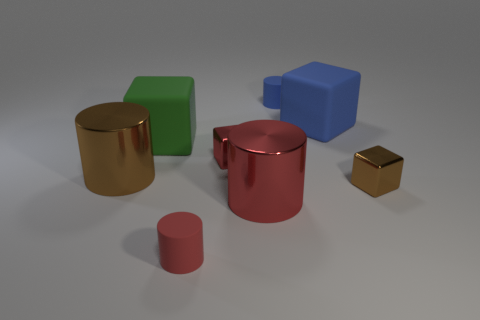Subtract all brown blocks. How many blocks are left? 3 Subtract all big red shiny cylinders. How many cylinders are left? 3 Add 1 big brown cylinders. How many objects exist? 9 Subtract all cyan blocks. Subtract all cyan cylinders. How many blocks are left? 4 Subtract all brown shiny cylinders. Subtract all tiny blue matte objects. How many objects are left? 6 Add 1 metallic things. How many metallic things are left? 5 Add 2 big gray matte spheres. How many big gray matte spheres exist? 2 Subtract 0 purple blocks. How many objects are left? 8 